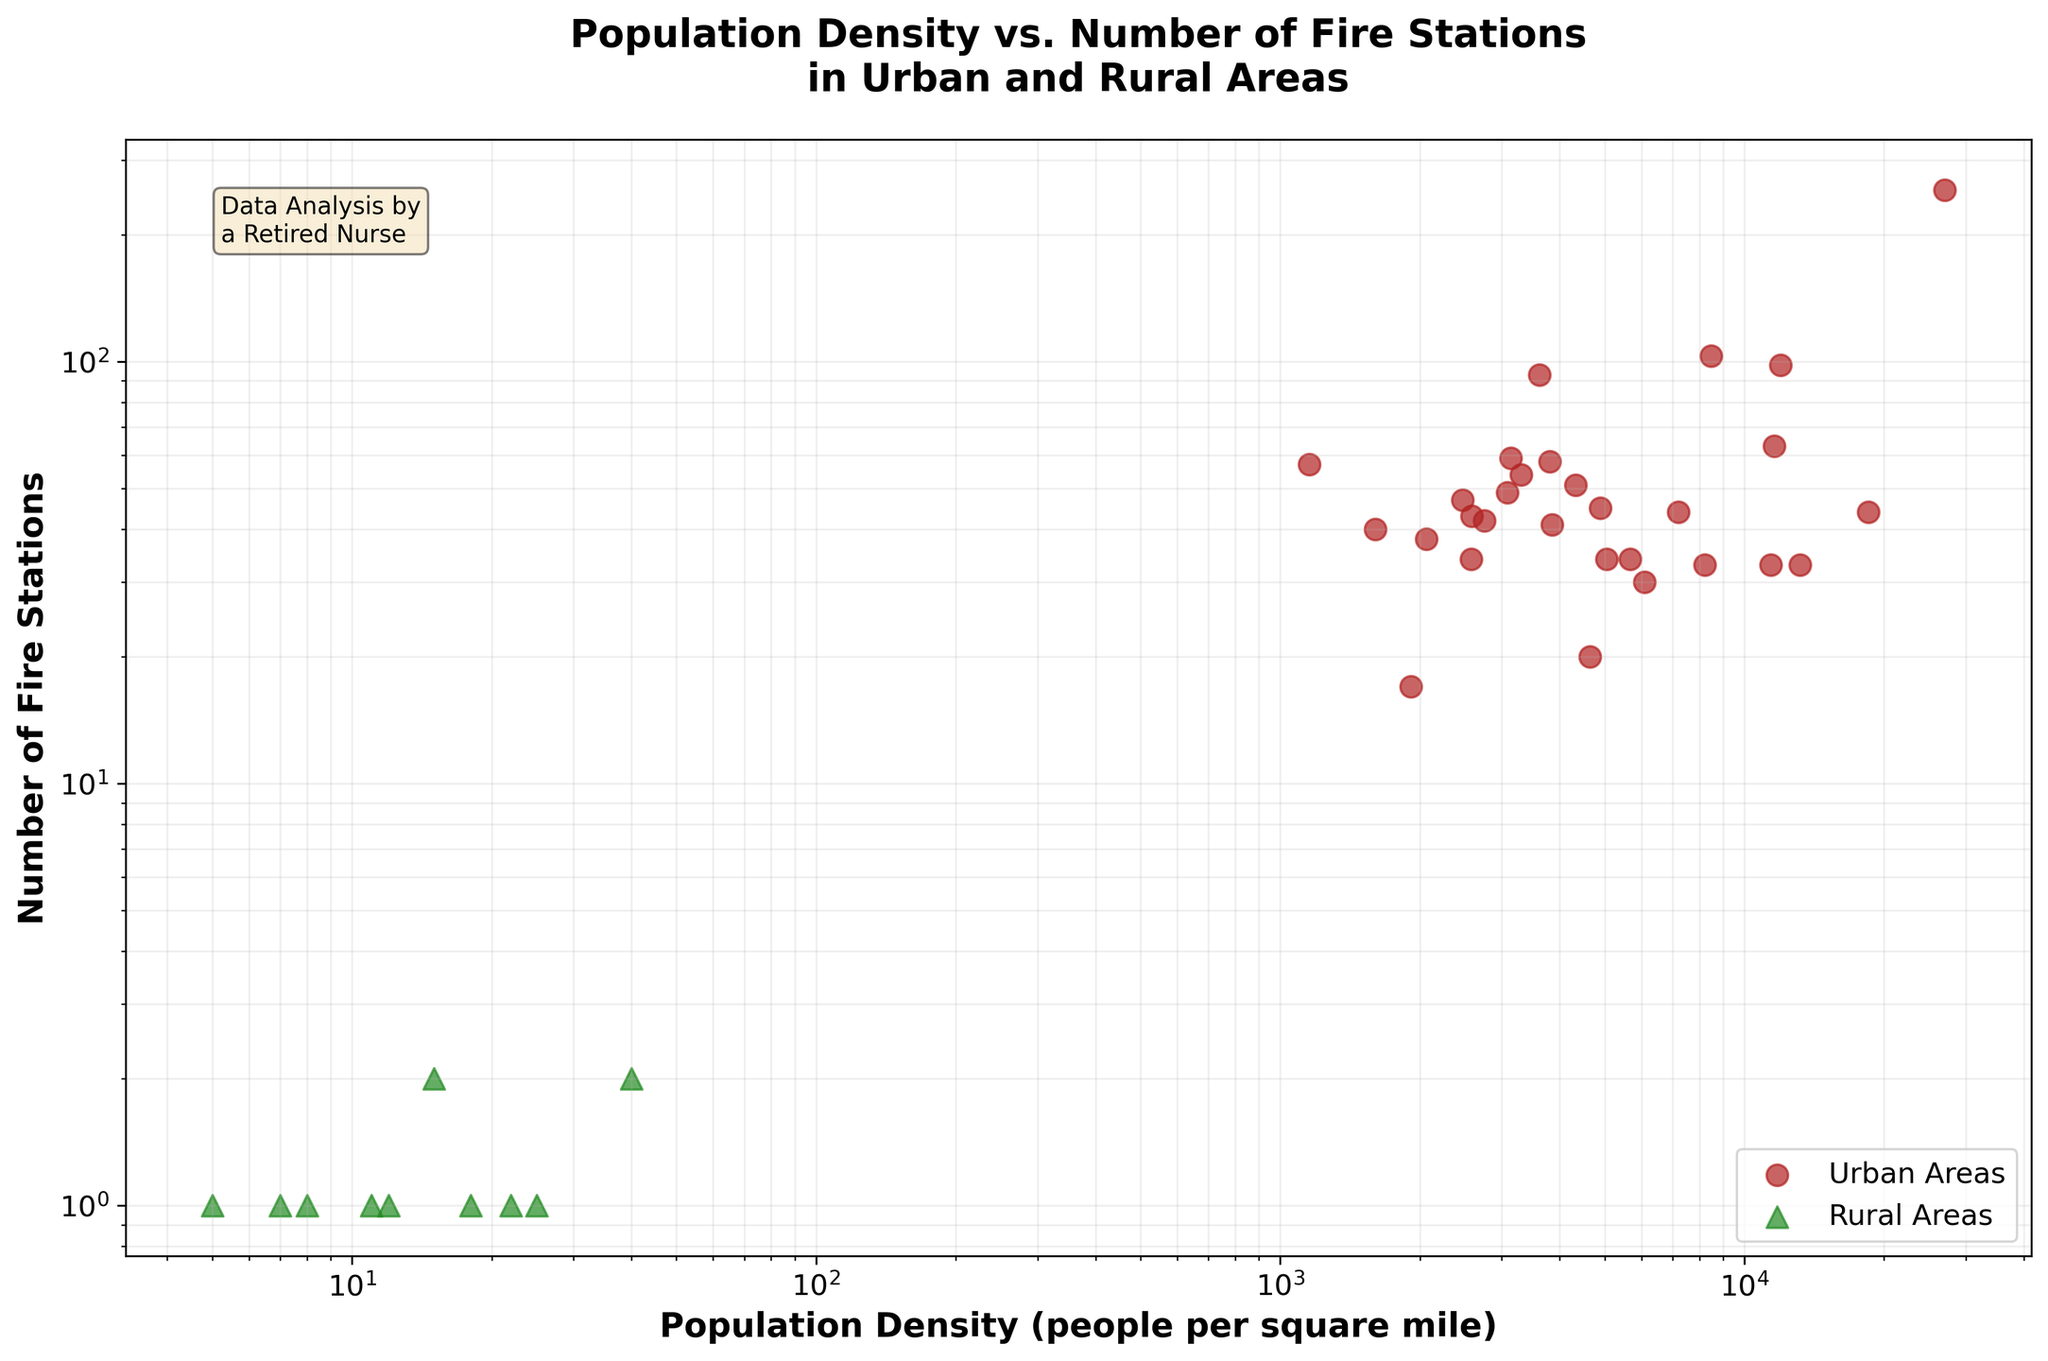How many urban areas are represented in the figure? Urban areas are depicted by circular ('o') markers. Counting these markers within the figure gives the number of urban areas.
Answer: 27 What color represents rural areas in the plot? Rural areas are indicated by the 'forestgreen' color as per the legend in the figure.
Answer: forestgreen Which city has the highest number of fire stations and what is the corresponding population density? The figure shows New York City having the highest count of fire stations, represented by the point at the upper-rightmost corner. The population density and number of fire stations for this point are 27012 and 255, respectively.
Answer: New York City, 27012 How does the number of fire stations in rural areas compare to urban areas? Rural areas, represented by triangles, have significantly fewer fire stations compared to urban areas. This is observed by comparing the cluster of lower points aligning with rural data to the higher clusters aligned with urban data.
Answer: Fewer in rural areas Which city has the lowest population density among urban areas and what is its number of fire stations? Within the urban area points, the one with the lowest population density is Jacksonville, with a population density of 1156 people per square mile and 57 fire stations.
Answer: Jacksonville, 1156, 57 What’s the general trend between population density and the number of fire stations in urban areas? Observing the scatter plot, there's an upward trend in the number of fire stations as the population density increases, indicating a direct correlation in urban areas.
Answer: Direct correlation Is there an urban area with fewer fire stations than any of the rural areas? All urban areas have more fire stations than any rural area, as urban points on the plot are higher up compared to the rural points.
Answer: No On average, do urban areas tend to have fewer or more fire stations compared to their population density when compared to rural areas? Urban areas, on average, have more fire stations relative to their population density. Comparing the clusters visually confirms urban areas lie higher in number of fire stations for a given population density.
Answer: More Are there more cities with population density below 100 people per square mile or above? The figure shows only a handful of rural points (below 100 people per square mile), while most urban points indicate population densities well above this threshold.
Answer: Above What's the relationship between population density and number of fire stations for rural areas? The scatter plot suggests there is a minimal correlation between population density and the number of fire stations for rural areas as the data points are quite scattered without a clear upward or downward trend.
Answer: Minimal correlation 